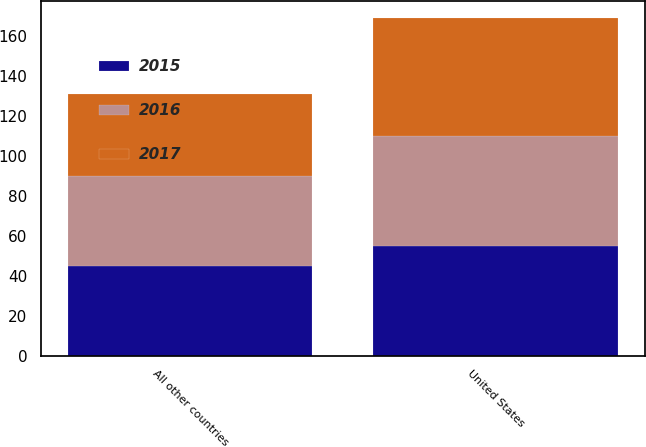Convert chart. <chart><loc_0><loc_0><loc_500><loc_500><stacked_bar_chart><ecel><fcel>United States<fcel>All other countries<nl><fcel>2017<fcel>59<fcel>41<nl><fcel>2016<fcel>55<fcel>45<nl><fcel>2015<fcel>55<fcel>45<nl></chart> 